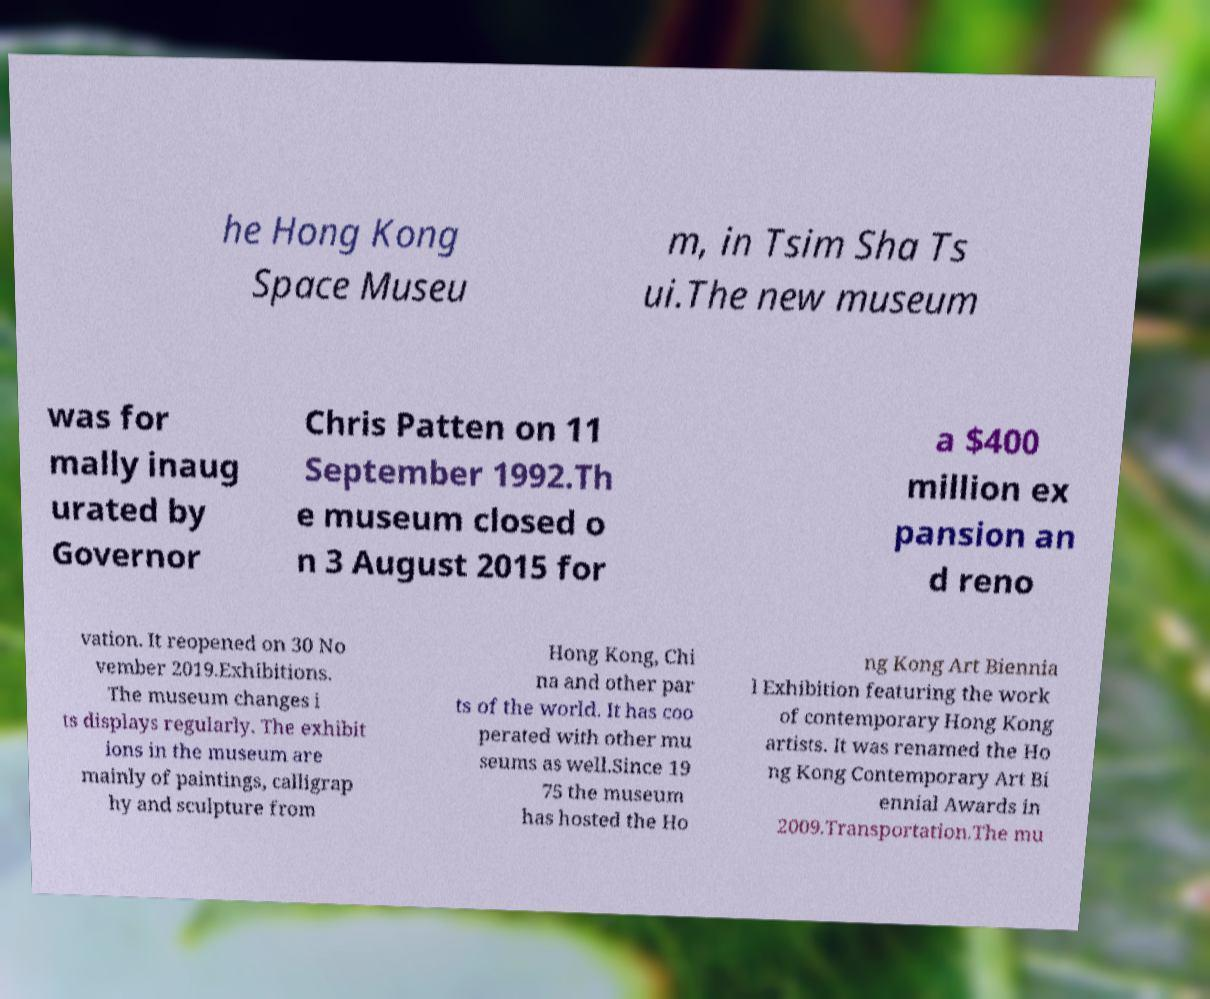Please read and relay the text visible in this image. What does it say? he Hong Kong Space Museu m, in Tsim Sha Ts ui.The new museum was for mally inaug urated by Governor Chris Patten on 11 September 1992.Th e museum closed o n 3 August 2015 for a $400 million ex pansion an d reno vation. It reopened on 30 No vember 2019.Exhibitions. The museum changes i ts displays regularly. The exhibit ions in the museum are mainly of paintings, calligrap hy and sculpture from Hong Kong, Chi na and other par ts of the world. It has coo perated with other mu seums as well.Since 19 75 the museum has hosted the Ho ng Kong Art Biennia l Exhibition featuring the work of contemporary Hong Kong artists. It was renamed the Ho ng Kong Contemporary Art Bi ennial Awards in 2009.Transportation.The mu 